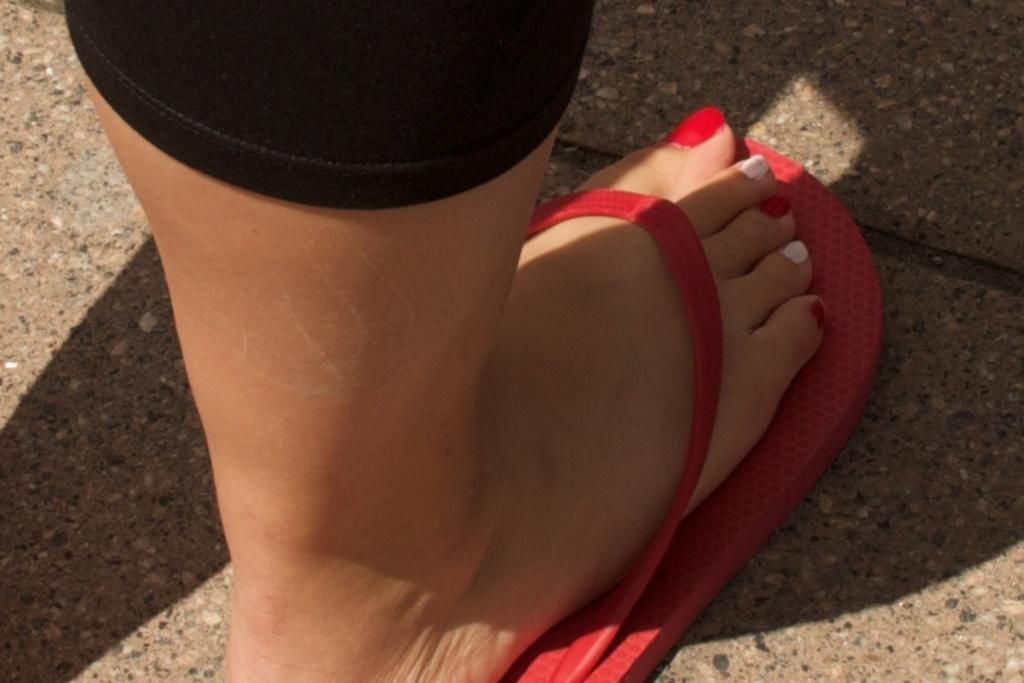What part of a person can be seen in the image? There is a leg of a person in the image. What type of footwear is the person wearing? The person is wearing red color rubber slippers. What can be observed about the person's toe nails? The person's toe fingers have nail polish. What colors are used for the nail polish? The nail polish is in red and white color. What rings can be seen on the person's fingers in the image? There are no rings visible in the image. What is the limit of the person's leg in the image? The image only shows a portion of the person's leg, so it is not possible to determine a limit. 